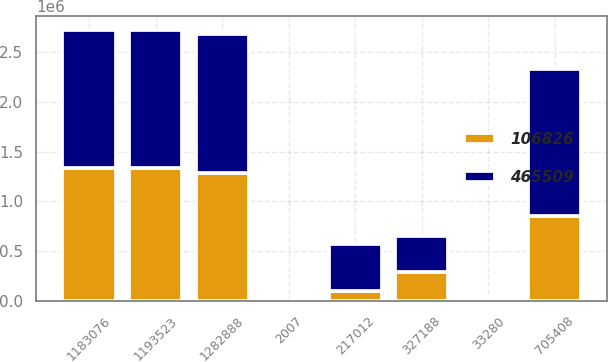<chart> <loc_0><loc_0><loc_500><loc_500><stacked_bar_chart><ecel><fcel>2007<fcel>1193523<fcel>1183076<fcel>1282888<fcel>705408<fcel>327188<fcel>33280<fcel>217012<nl><fcel>106826<fcel>2006<fcel>1.33673e+06<fcel>1.33168e+06<fcel>1.28106e+06<fcel>851172<fcel>298111<fcel>24946<fcel>106826<nl><fcel>465509<fcel>2005<fcel>1.38617e+06<fcel>1.38369e+06<fcel>1.39613e+06<fcel>1.47956e+06<fcel>358101<fcel>23981<fcel>465509<nl></chart> 